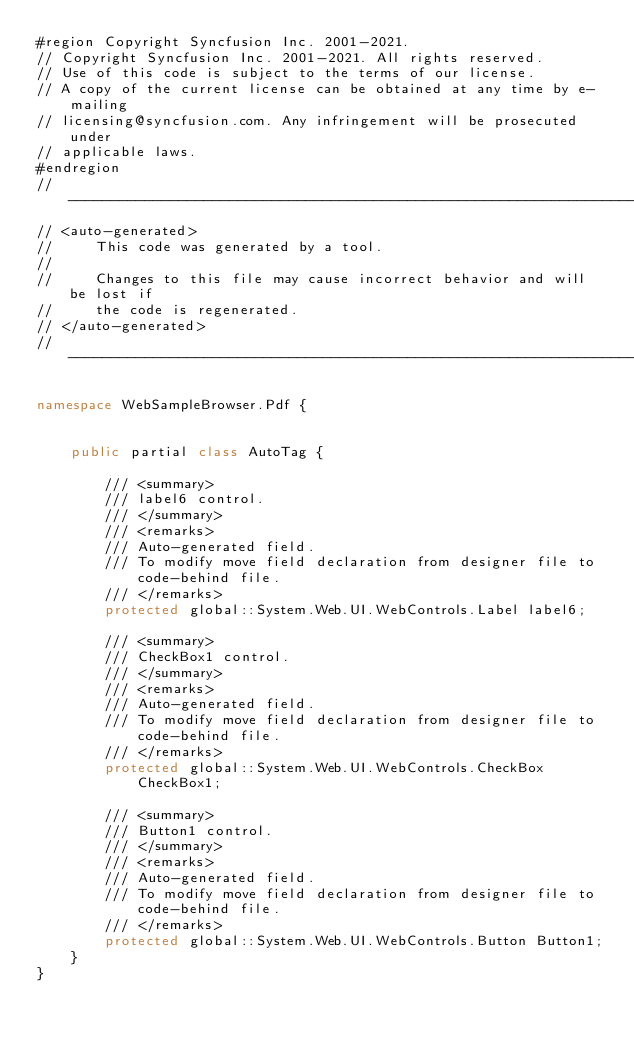Convert code to text. <code><loc_0><loc_0><loc_500><loc_500><_C#_>#region Copyright Syncfusion Inc. 2001-2021.
// Copyright Syncfusion Inc. 2001-2021. All rights reserved.
// Use of this code is subject to the terms of our license.
// A copy of the current license can be obtained at any time by e-mailing
// licensing@syncfusion.com. Any infringement will be prosecuted under
// applicable laws. 
#endregion
//------------------------------------------------------------------------------
// <auto-generated>
//     This code was generated by a tool.
//
//     Changes to this file may cause incorrect behavior and will be lost if
//     the code is regenerated. 
// </auto-generated>
//------------------------------------------------------------------------------

namespace WebSampleBrowser.Pdf {
    
    
    public partial class AutoTag {
        
        /// <summary>
        /// label6 control.
        /// </summary>
        /// <remarks>
        /// Auto-generated field.
        /// To modify move field declaration from designer file to code-behind file.
        /// </remarks>
        protected global::System.Web.UI.WebControls.Label label6;
        
        /// <summary>
        /// CheckBox1 control.
        /// </summary>
        /// <remarks>
        /// Auto-generated field.
        /// To modify move field declaration from designer file to code-behind file.
        /// </remarks>
        protected global::System.Web.UI.WebControls.CheckBox CheckBox1;
        
        /// <summary>
        /// Button1 control.
        /// </summary>
        /// <remarks>
        /// Auto-generated field.
        /// To modify move field declaration from designer file to code-behind file.
        /// </remarks>
        protected global::System.Web.UI.WebControls.Button Button1;
    }
}
</code> 